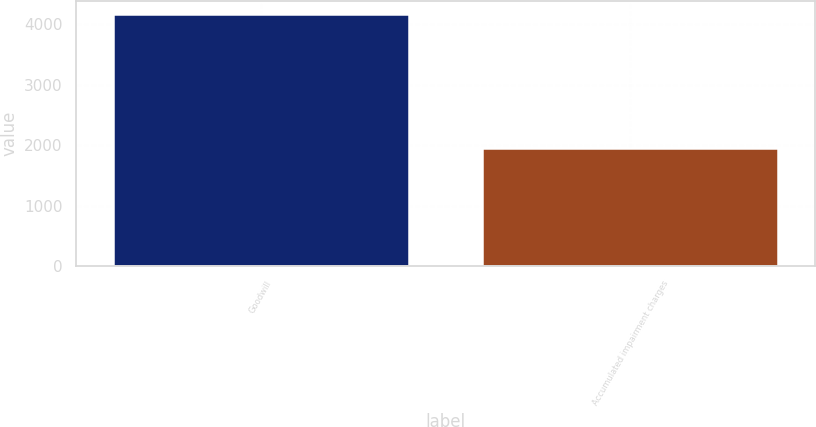<chart> <loc_0><loc_0><loc_500><loc_500><bar_chart><fcel>Goodwill<fcel>Accumulated impairment charges<nl><fcel>4174.1<fcel>1953.8<nl></chart> 